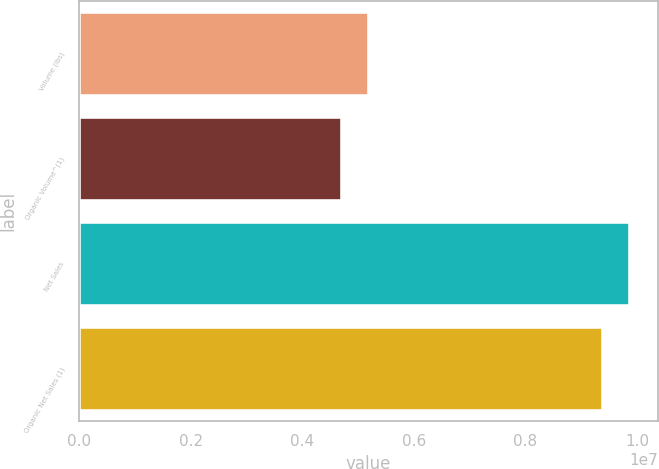Convert chart to OTSL. <chart><loc_0><loc_0><loc_500><loc_500><bar_chart><fcel>Volume (lbs)<fcel>Organic Volume^(1)<fcel>Net Sales<fcel>Organic Net Sales (1)<nl><fcel>5.20404e+06<fcel>4.72164e+06<fcel>9.88201e+06<fcel>9.3996e+06<nl></chart> 